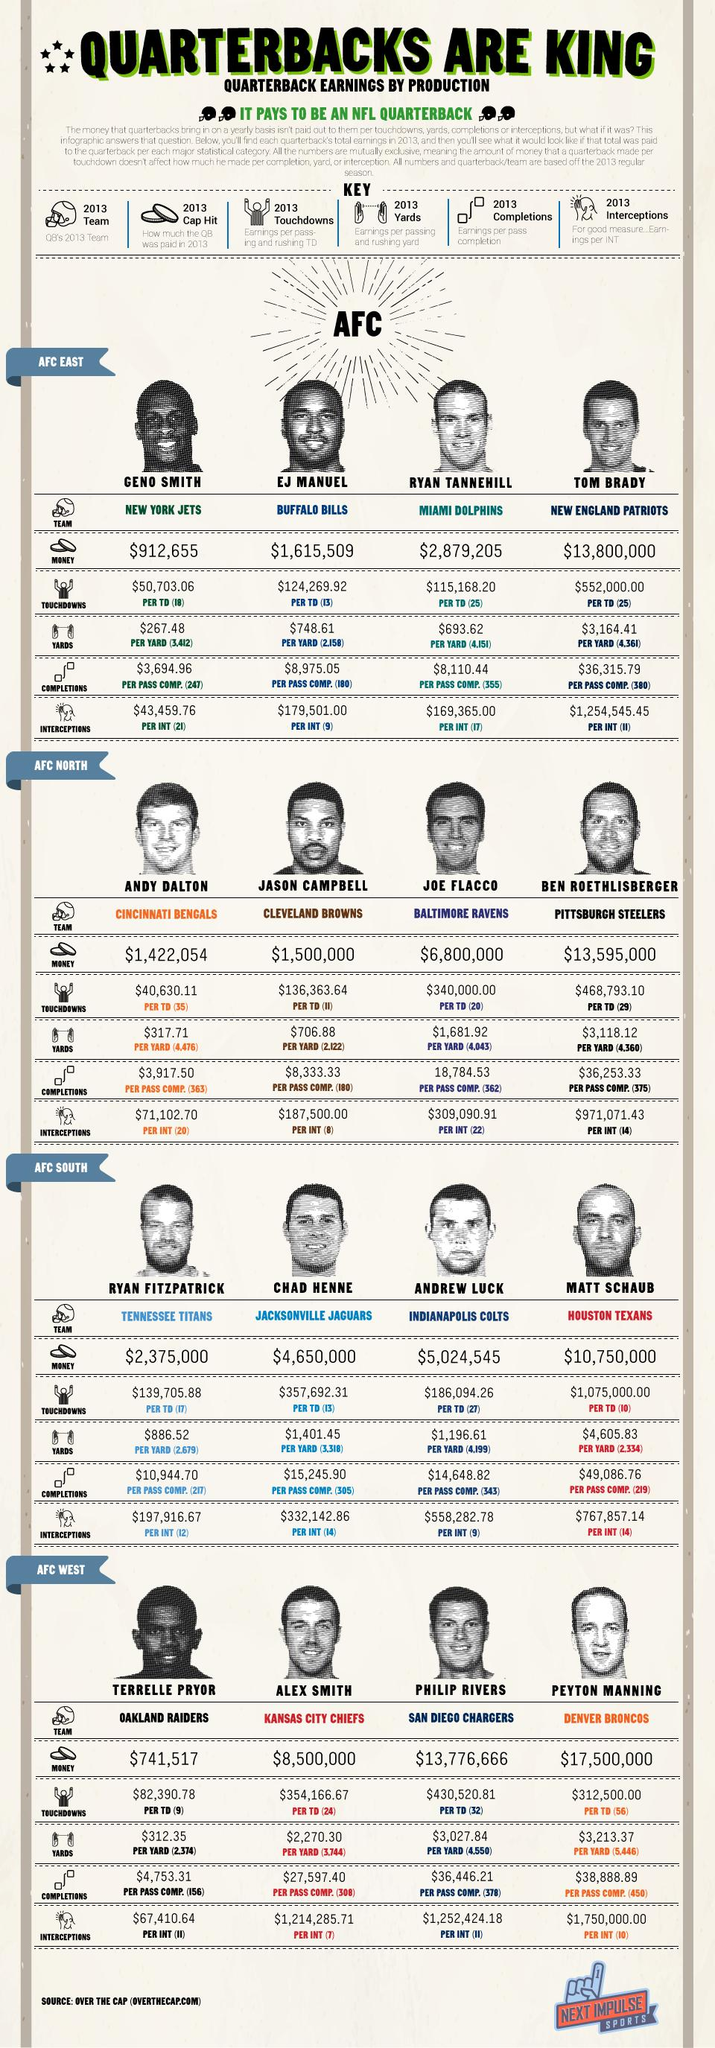Draw attention to some important aspects in this diagram. Earnings per pass completion by EJ Manuel in 2013 were $8,975.05. The AFC West contains 4 teams. The Buffalo Bills played in the AFC East division of the National Football League (NFL) in the year 2013. The AFC South has four teams. 